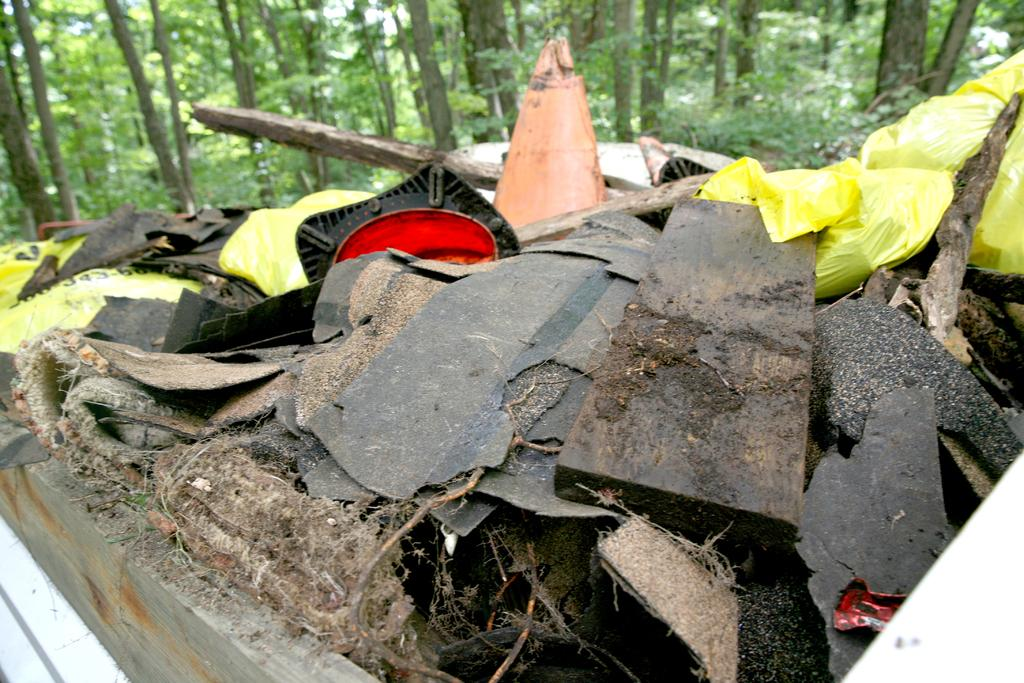What is present in the image that should not be there? There is garbage in the image. What can be seen in the distance in the image? There are trees in the background of the image. How many feet are visible in the image? There are no feet visible in the image. Is there a person holding a chain in the image? There is no person or chain present in the image. 